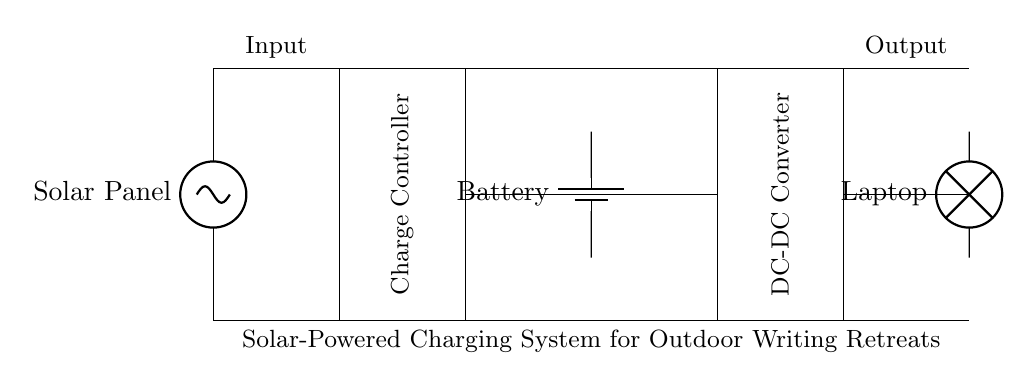What is the primary energy source for this system? The primary energy source is the solar panel, which converts sunlight into electrical energy.
Answer: solar panel What component regulates the power output from the solar panel? The charge controller manages the power output from the solar panel to ensure the battery is charged safely and effectively.
Answer: charge controller How many main components are in this charging system? There are five main components: the solar panel, charge controller, battery, DC-DC converter, and load (laptop).
Answer: five What role does the DC-DC converter play in this circuit? The DC-DC converter adjusts the voltage from the battery to match the requirements of the load (laptop).
Answer: adjusts voltage Which component stores energy for later use? The battery is responsible for storing electrical energy generated by the solar panel for later use by the load.
Answer: battery What is the voltage supplied to the laptop? The voltage supplied to the laptop is determined by the output of the DC-DC converter, which is adjusted to meet the laptop's requirements.
Answer: varies (depends on converter) What indicates the output side of the circuit? The output side of the circuit is indicated by the connection to the laptop, showing where power is delivered from the charging system.
Answer: laptop 